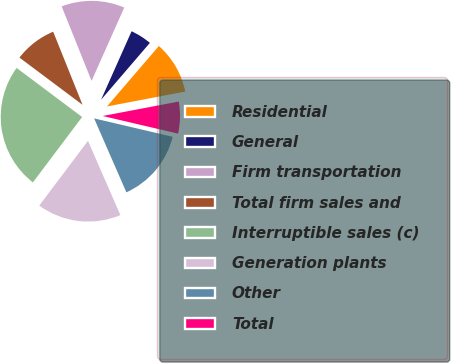Convert chart to OTSL. <chart><loc_0><loc_0><loc_500><loc_500><pie_chart><fcel>Residential<fcel>General<fcel>Firm transportation<fcel>Total firm sales and<fcel>Interruptible sales (c)<fcel>Generation plants<fcel>Other<fcel>Total<nl><fcel>10.72%<fcel>4.62%<fcel>12.75%<fcel>8.69%<fcel>24.96%<fcel>16.82%<fcel>14.79%<fcel>6.65%<nl></chart> 